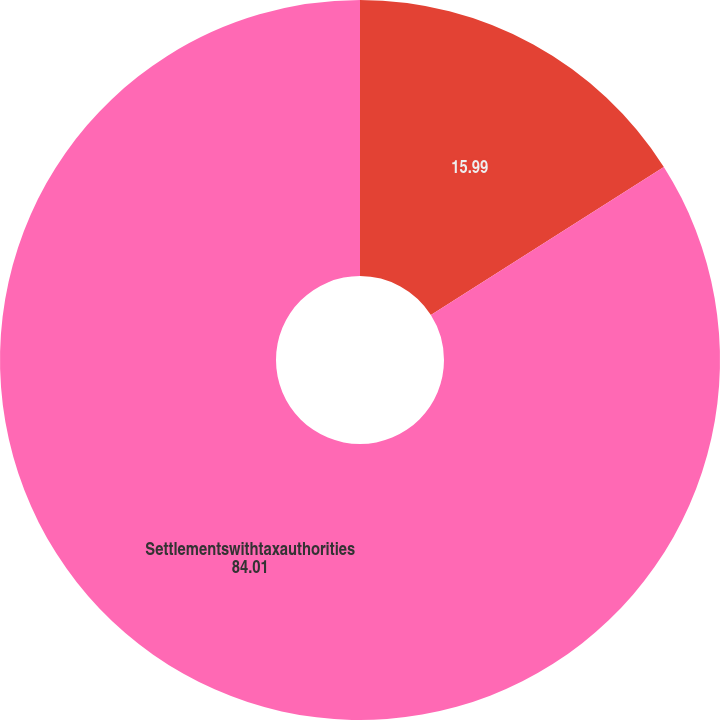<chart> <loc_0><loc_0><loc_500><loc_500><pie_chart><ecel><fcel>Settlementswithtaxauthorities<nl><fcel>15.99%<fcel>84.01%<nl></chart> 